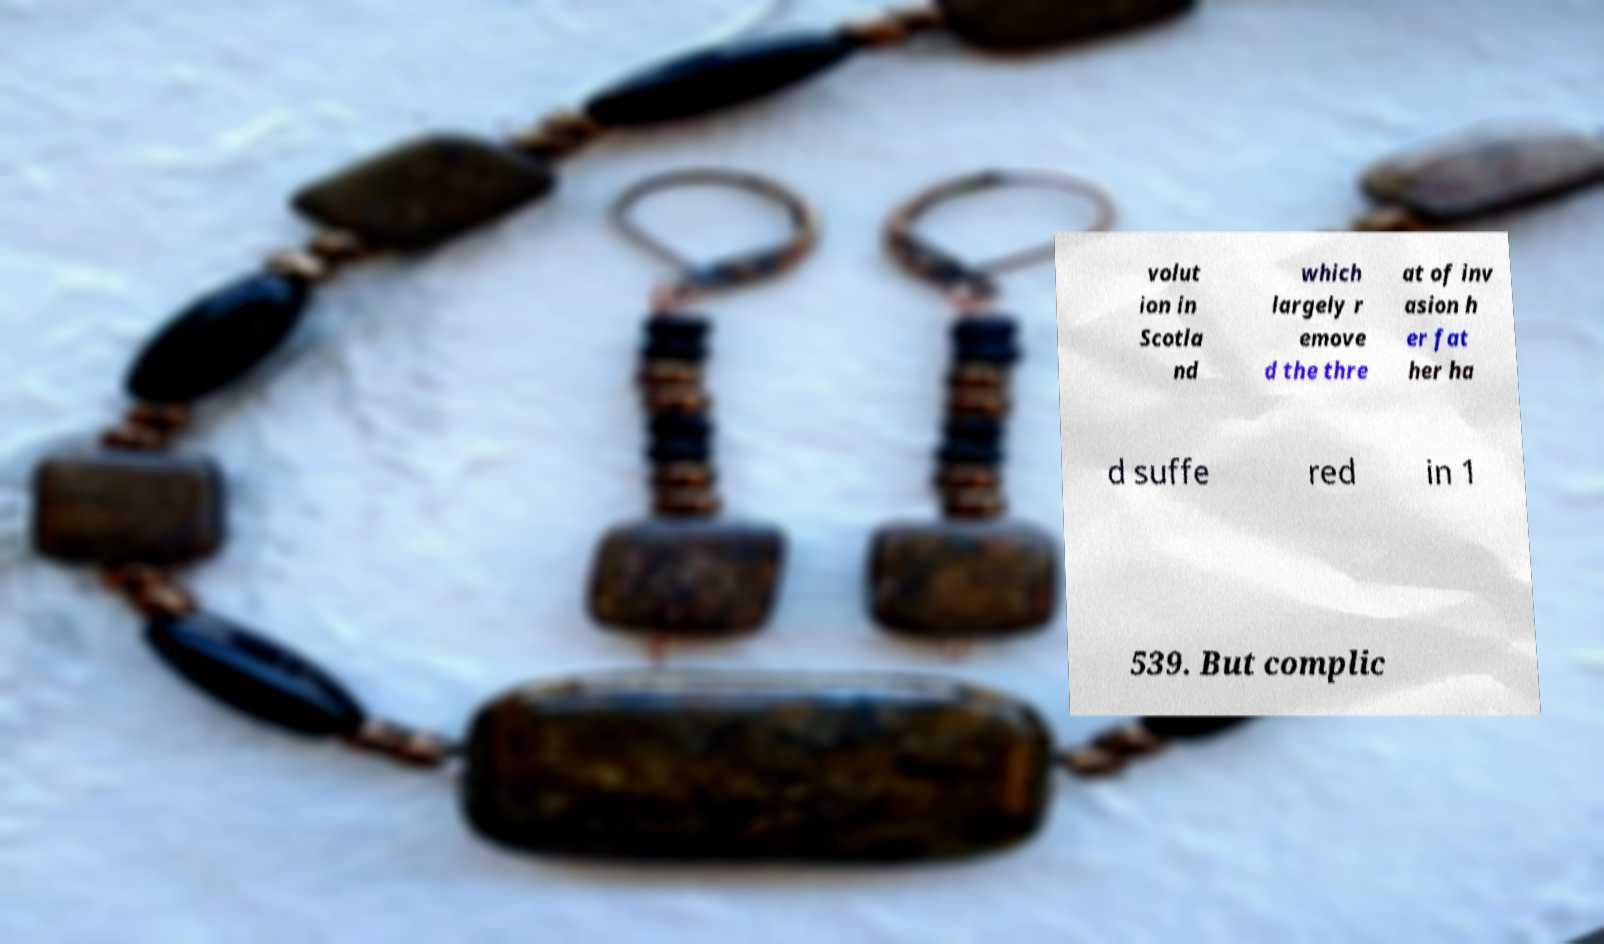For documentation purposes, I need the text within this image transcribed. Could you provide that? volut ion in Scotla nd which largely r emove d the thre at of inv asion h er fat her ha d suffe red in 1 539. But complic 